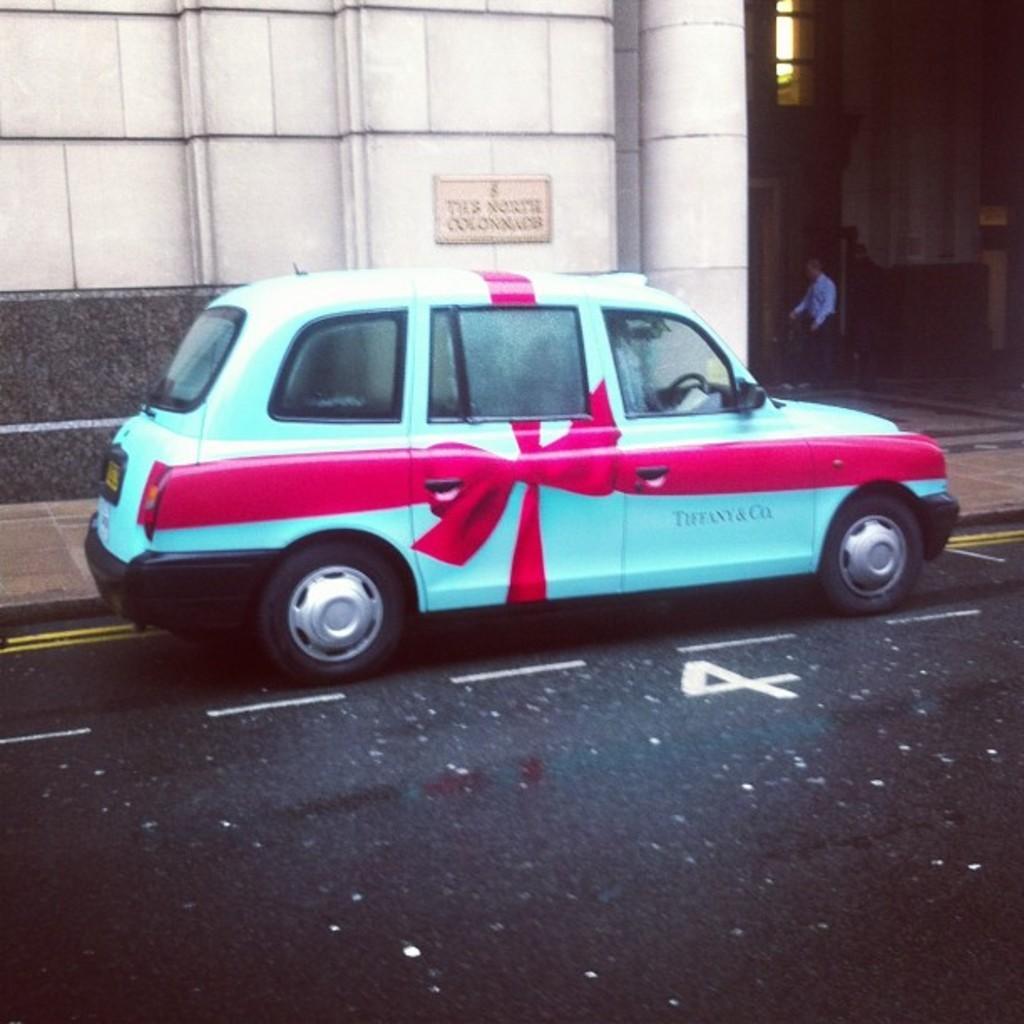Can you describe this image briefly? In this picture I can see a vehicle on the road. I can see a person standing, and in the background there is a building. 